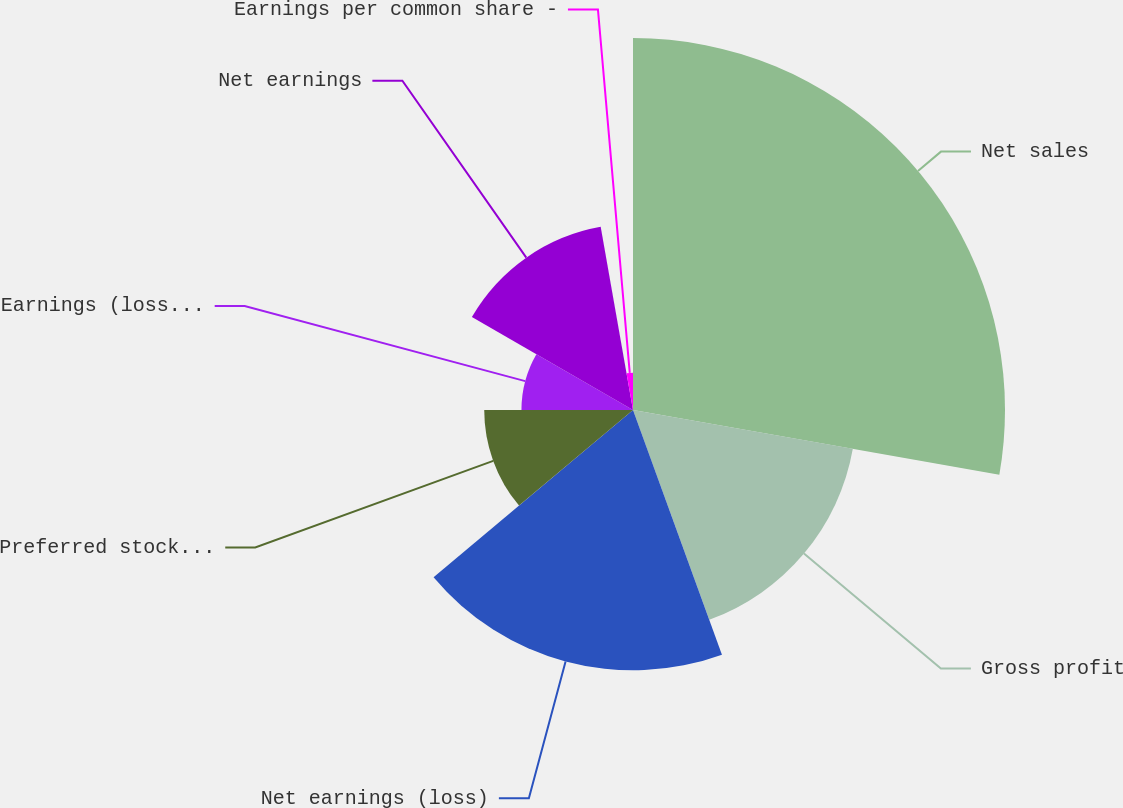Convert chart to OTSL. <chart><loc_0><loc_0><loc_500><loc_500><pie_chart><fcel>Net sales<fcel>Gross profit<fcel>Net earnings (loss)<fcel>Preferred stock dividends<fcel>Earnings (loss) per common<fcel>Net earnings<fcel>Earnings per common share -<nl><fcel>27.78%<fcel>16.67%<fcel>19.44%<fcel>11.11%<fcel>8.33%<fcel>13.89%<fcel>2.78%<nl></chart> 